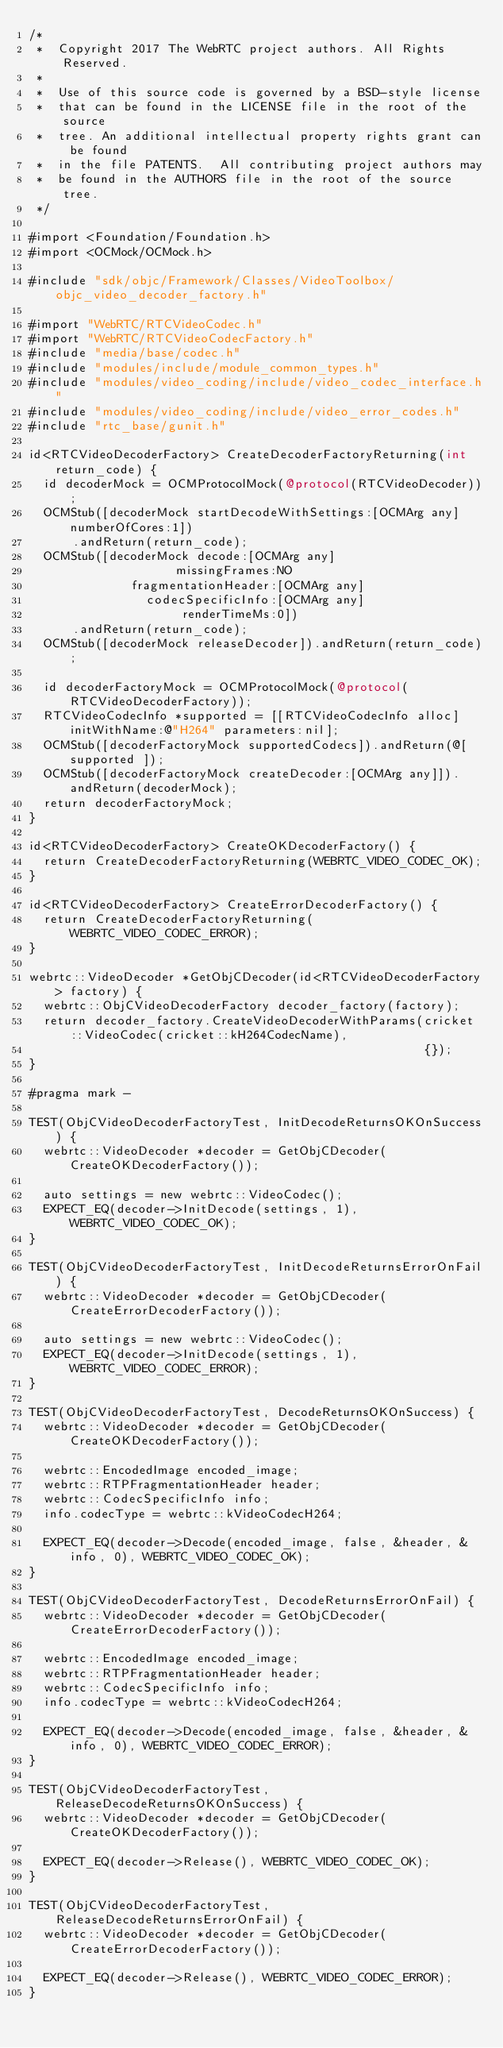<code> <loc_0><loc_0><loc_500><loc_500><_ObjectiveC_>/*
 *  Copyright 2017 The WebRTC project authors. All Rights Reserved.
 *
 *  Use of this source code is governed by a BSD-style license
 *  that can be found in the LICENSE file in the root of the source
 *  tree. An additional intellectual property rights grant can be found
 *  in the file PATENTS.  All contributing project authors may
 *  be found in the AUTHORS file in the root of the source tree.
 */

#import <Foundation/Foundation.h>
#import <OCMock/OCMock.h>

#include "sdk/objc/Framework/Classes/VideoToolbox/objc_video_decoder_factory.h"

#import "WebRTC/RTCVideoCodec.h"
#import "WebRTC/RTCVideoCodecFactory.h"
#include "media/base/codec.h"
#include "modules/include/module_common_types.h"
#include "modules/video_coding/include/video_codec_interface.h"
#include "modules/video_coding/include/video_error_codes.h"
#include "rtc_base/gunit.h"

id<RTCVideoDecoderFactory> CreateDecoderFactoryReturning(int return_code) {
  id decoderMock = OCMProtocolMock(@protocol(RTCVideoDecoder));
  OCMStub([decoderMock startDecodeWithSettings:[OCMArg any] numberOfCores:1])
      .andReturn(return_code);
  OCMStub([decoderMock decode:[OCMArg any]
                    missingFrames:NO
              fragmentationHeader:[OCMArg any]
                codecSpecificInfo:[OCMArg any]
                     renderTimeMs:0])
      .andReturn(return_code);
  OCMStub([decoderMock releaseDecoder]).andReturn(return_code);

  id decoderFactoryMock = OCMProtocolMock(@protocol(RTCVideoDecoderFactory));
  RTCVideoCodecInfo *supported = [[RTCVideoCodecInfo alloc] initWithName:@"H264" parameters:nil];
  OCMStub([decoderFactoryMock supportedCodecs]).andReturn(@[ supported ]);
  OCMStub([decoderFactoryMock createDecoder:[OCMArg any]]).andReturn(decoderMock);
  return decoderFactoryMock;
}

id<RTCVideoDecoderFactory> CreateOKDecoderFactory() {
  return CreateDecoderFactoryReturning(WEBRTC_VIDEO_CODEC_OK);
}

id<RTCVideoDecoderFactory> CreateErrorDecoderFactory() {
  return CreateDecoderFactoryReturning(WEBRTC_VIDEO_CODEC_ERROR);
}

webrtc::VideoDecoder *GetObjCDecoder(id<RTCVideoDecoderFactory> factory) {
  webrtc::ObjCVideoDecoderFactory decoder_factory(factory);
  return decoder_factory.CreateVideoDecoderWithParams(cricket::VideoCodec(cricket::kH264CodecName),
                                                      {});
}

#pragma mark -

TEST(ObjCVideoDecoderFactoryTest, InitDecodeReturnsOKOnSuccess) {
  webrtc::VideoDecoder *decoder = GetObjCDecoder(CreateOKDecoderFactory());

  auto settings = new webrtc::VideoCodec();
  EXPECT_EQ(decoder->InitDecode(settings, 1), WEBRTC_VIDEO_CODEC_OK);
}

TEST(ObjCVideoDecoderFactoryTest, InitDecodeReturnsErrorOnFail) {
  webrtc::VideoDecoder *decoder = GetObjCDecoder(CreateErrorDecoderFactory());

  auto settings = new webrtc::VideoCodec();
  EXPECT_EQ(decoder->InitDecode(settings, 1), WEBRTC_VIDEO_CODEC_ERROR);
}

TEST(ObjCVideoDecoderFactoryTest, DecodeReturnsOKOnSuccess) {
  webrtc::VideoDecoder *decoder = GetObjCDecoder(CreateOKDecoderFactory());

  webrtc::EncodedImage encoded_image;
  webrtc::RTPFragmentationHeader header;
  webrtc::CodecSpecificInfo info;
  info.codecType = webrtc::kVideoCodecH264;

  EXPECT_EQ(decoder->Decode(encoded_image, false, &header, &info, 0), WEBRTC_VIDEO_CODEC_OK);
}

TEST(ObjCVideoDecoderFactoryTest, DecodeReturnsErrorOnFail) {
  webrtc::VideoDecoder *decoder = GetObjCDecoder(CreateErrorDecoderFactory());

  webrtc::EncodedImage encoded_image;
  webrtc::RTPFragmentationHeader header;
  webrtc::CodecSpecificInfo info;
  info.codecType = webrtc::kVideoCodecH264;

  EXPECT_EQ(decoder->Decode(encoded_image, false, &header, &info, 0), WEBRTC_VIDEO_CODEC_ERROR);
}

TEST(ObjCVideoDecoderFactoryTest, ReleaseDecodeReturnsOKOnSuccess) {
  webrtc::VideoDecoder *decoder = GetObjCDecoder(CreateOKDecoderFactory());

  EXPECT_EQ(decoder->Release(), WEBRTC_VIDEO_CODEC_OK);
}

TEST(ObjCVideoDecoderFactoryTest, ReleaseDecodeReturnsErrorOnFail) {
  webrtc::VideoDecoder *decoder = GetObjCDecoder(CreateErrorDecoderFactory());

  EXPECT_EQ(decoder->Release(), WEBRTC_VIDEO_CODEC_ERROR);
}
</code> 